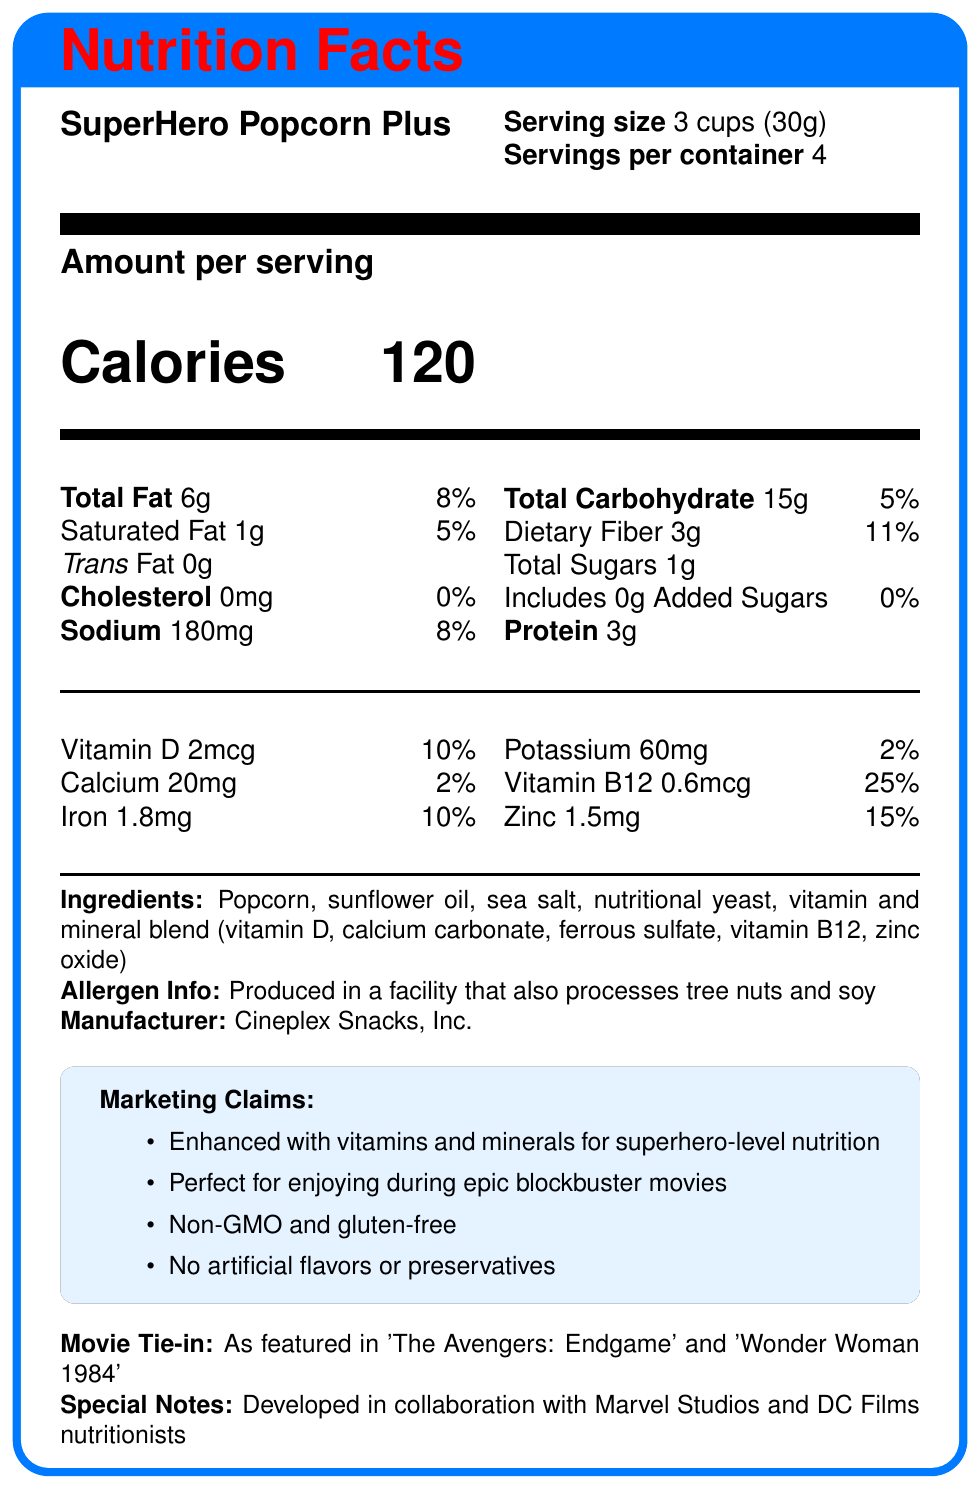What is the serving size of SuperHero Popcorn Plus? The document states that the serving size is 3 cups (30g).
Answer: 3 cups (30g) How many servings are there per container? The document specifies that there are 4 servings per container.
Answer: 4 How many calories are in one serving of SuperHero Popcorn Plus? It is mentioned under "Amount per serving" that there are 120 calories per serving.
Answer: 120 What is the total fat content per serving? The document lists the total fat as 6g per serving.
Answer: 6g Does the SuperHero Popcorn Plus contain any trans fat? The document indicates that Trans Fat is 0g.
Answer: No What is the sodium content per serving? Sodium content is listed as 180mg per serving.
Answer: 180mg How much dietary fiber does one serving of the popcorn provide? The dietary fiber amount is 3g per serving.
Answer: 3g How many grams of added sugars are in a serving? The document specifies that added sugars are 0g per serving.
Answer: 0g What is the daily value percentage for Vitamin B12 in one serving? Vitamin B12 has a daily value of 25%.
Answer: 25% What is the manufacturer of the SuperHero Popcorn Plus? The manufacturer is mentioned as Cineplex Snacks, Inc.
Answer: Cineplex Snacks, Inc. Does SuperHero Popcorn Plus contain any cholesterol? The cholesterol content is 0mg, indicating no cholesterol.
Answer: No What is one of the marketing claims for SuperHero Popcorn Plus? A. Contains artificial flavors B. GMO-free C. High in saturated fat D. Low in protein One of the marketing claims is "Non-GMO and gluten-free."
Answer: B Which of the following vitamins is included in the vitamin and mineral blend? A. Vitamin C B. Vitamin B12 C. Vitamin E D. Vitamin K Vitamin B12 is listed as part of the vitamin and mineral blend.
Answer: B Is the popcorn produced in a facility that processes tree nuts? The allergen info states that it is produced in a facility that also processes tree nuts and soy.
Answer: Yes Summarize the main idea of the document. The document gives detailed information about the nutritional content, ingredients, and various claims about the SuperHero Popcorn Plus product.
Answer: The document provides Nutrition Facts for SuperHero Popcorn Plus, listing serving size, calories, fat, sodium, carbohydrates, fibers, sugars, protein, and various vitamins and minerals. It also includes ingredients, allergen info, manufacturer details, marketing claims, a movie tie-in, and special notes. Who developed the SuperHero Popcorn Plus recipe? The document does not specify who exactly developed the recipe, only that it was done in collaboration with Marvel Studios and DC Films nutritionists.
Answer: I don't know How much iron does each serving of the popcorn contain? The document states that there is 1.8mg of iron per serving.
Answer: 1.8mg Is the popcorn gluten-free? One of the marketing claims is that it is "Non-GMO and gluten-free."
Answer: Yes 